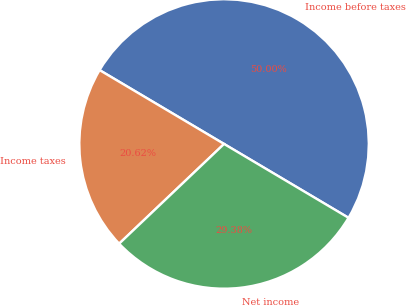Convert chart. <chart><loc_0><loc_0><loc_500><loc_500><pie_chart><fcel>Income before taxes<fcel>Income taxes<fcel>Net income<nl><fcel>50.0%<fcel>20.62%<fcel>29.38%<nl></chart> 